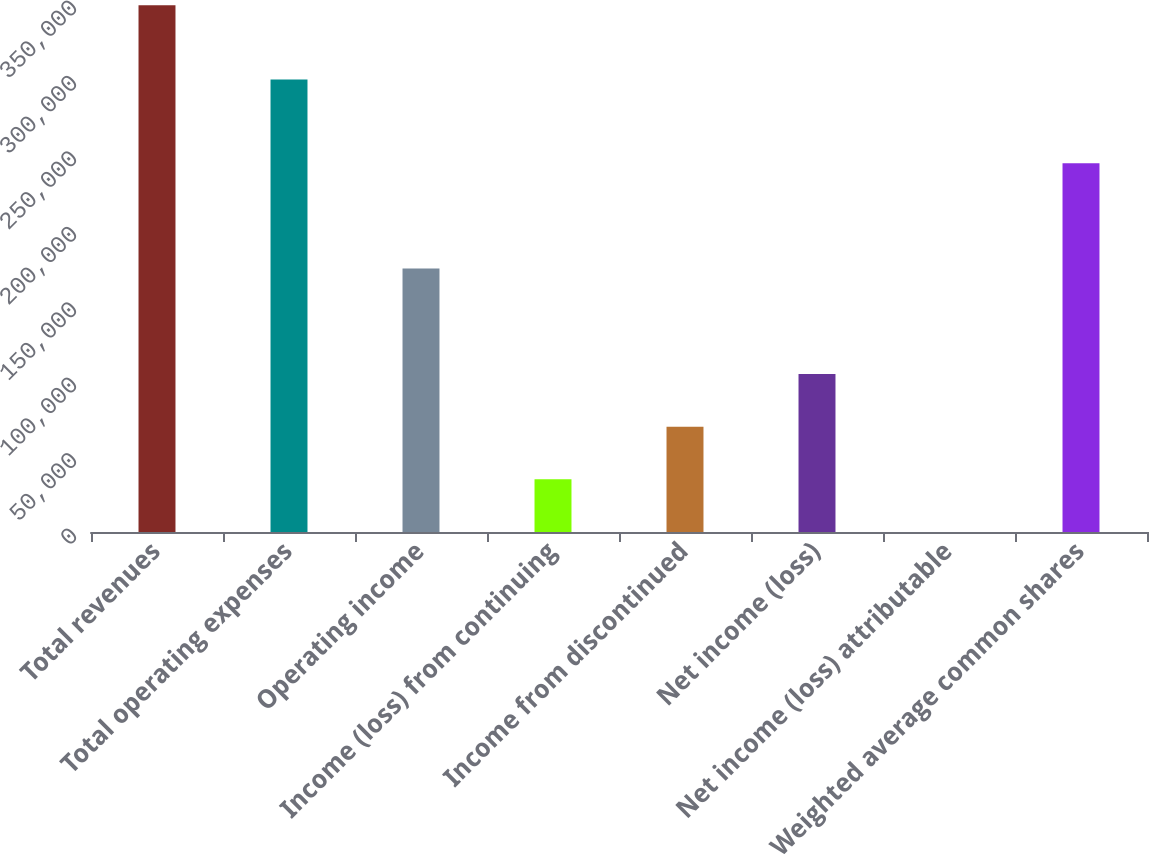Convert chart to OTSL. <chart><loc_0><loc_0><loc_500><loc_500><bar_chart><fcel>Total revenues<fcel>Total operating expenses<fcel>Operating income<fcel>Income (loss) from continuing<fcel>Income from discontinued<fcel>Net income (loss)<fcel>Net income (loss) attributable<fcel>Weighted average common shares<nl><fcel>349245<fcel>299995<fcel>174623<fcel>34924.8<fcel>69849.2<fcel>104774<fcel>0.3<fcel>244472<nl></chart> 